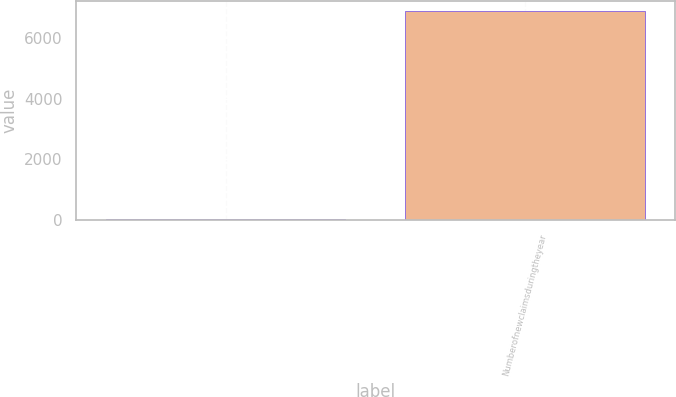<chart> <loc_0><loc_0><loc_500><loc_500><bar_chart><ecel><fcel>Numberofnewclaimsduringtheyear<nl><fcel>34.9<fcel>6882.71<nl></chart> 